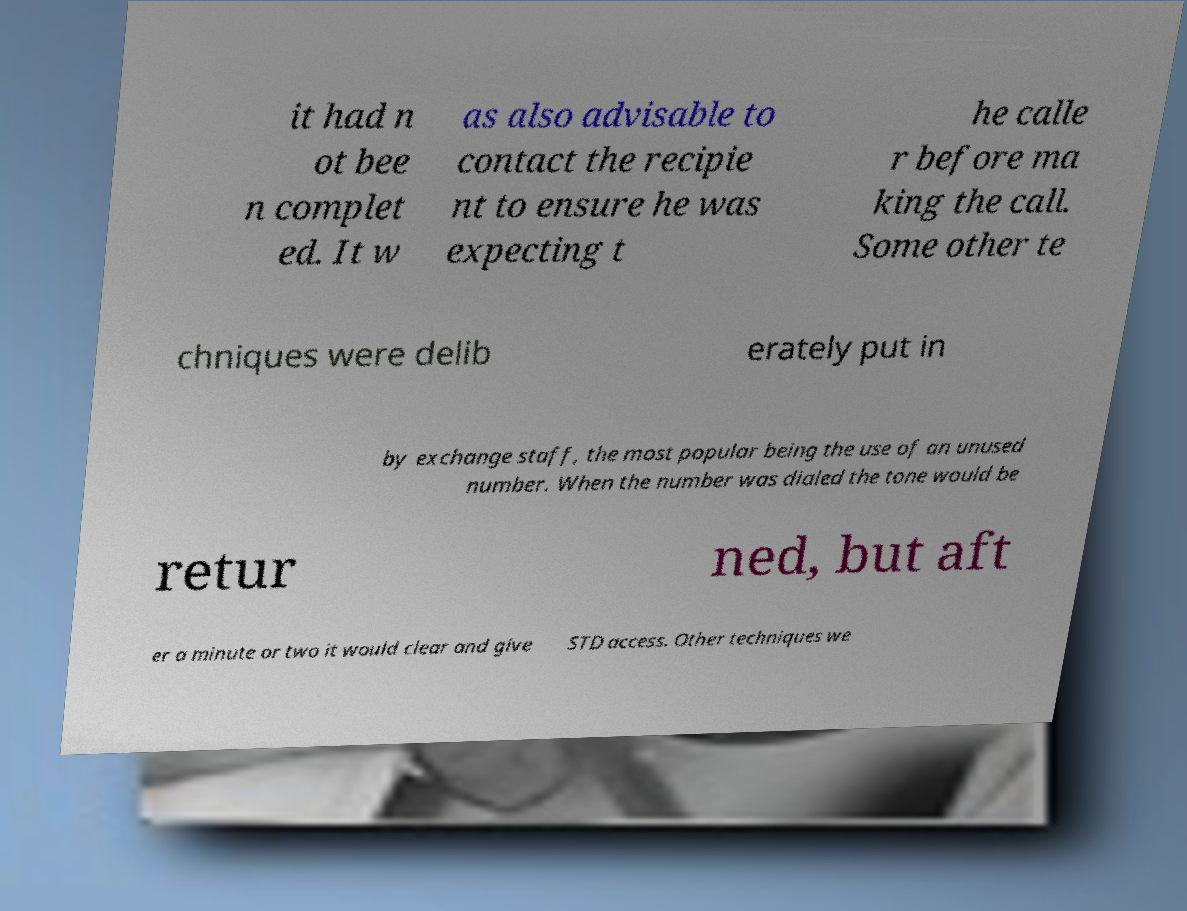Can you read and provide the text displayed in the image?This photo seems to have some interesting text. Can you extract and type it out for me? it had n ot bee n complet ed. It w as also advisable to contact the recipie nt to ensure he was expecting t he calle r before ma king the call. Some other te chniques were delib erately put in by exchange staff, the most popular being the use of an unused number. When the number was dialed the tone would be retur ned, but aft er a minute or two it would clear and give STD access. Other techniques we 